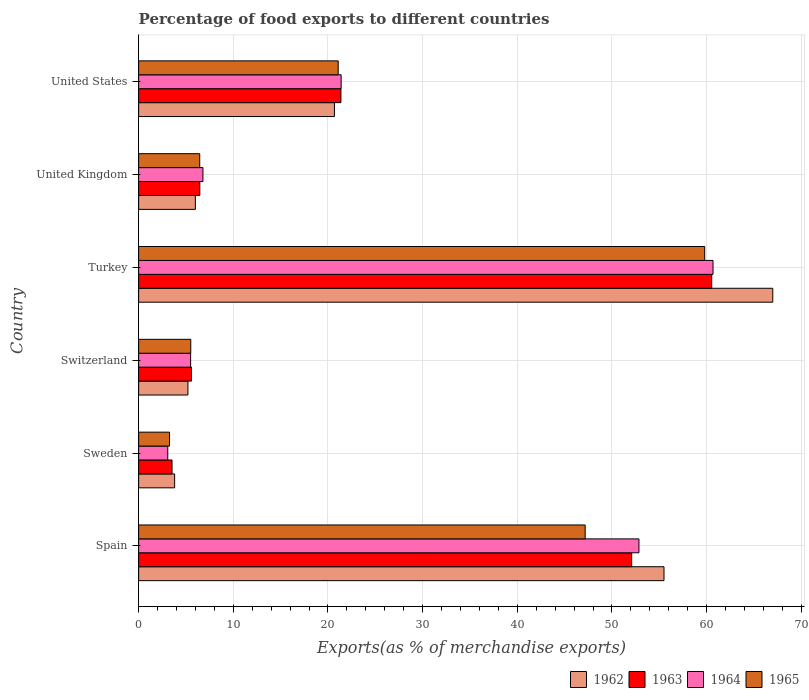How many different coloured bars are there?
Provide a short and direct response. 4. Are the number of bars on each tick of the Y-axis equal?
Provide a succinct answer. Yes. What is the label of the 4th group of bars from the top?
Offer a terse response. Switzerland. In how many cases, is the number of bars for a given country not equal to the number of legend labels?
Your response must be concise. 0. What is the percentage of exports to different countries in 1963 in Spain?
Provide a short and direct response. 52.09. Across all countries, what is the maximum percentage of exports to different countries in 1962?
Your answer should be very brief. 66.99. Across all countries, what is the minimum percentage of exports to different countries in 1965?
Your response must be concise. 3.27. What is the total percentage of exports to different countries in 1965 in the graph?
Ensure brevity in your answer.  143.28. What is the difference between the percentage of exports to different countries in 1965 in Sweden and that in Turkey?
Your answer should be very brief. -56.53. What is the difference between the percentage of exports to different countries in 1962 in Sweden and the percentage of exports to different countries in 1965 in United Kingdom?
Your answer should be very brief. -2.65. What is the average percentage of exports to different countries in 1963 per country?
Offer a terse response. 24.93. What is the difference between the percentage of exports to different countries in 1962 and percentage of exports to different countries in 1964 in Turkey?
Make the answer very short. 6.31. What is the ratio of the percentage of exports to different countries in 1962 in Switzerland to that in United States?
Your answer should be compact. 0.25. Is the difference between the percentage of exports to different countries in 1962 in Sweden and United Kingdom greater than the difference between the percentage of exports to different countries in 1964 in Sweden and United Kingdom?
Give a very brief answer. Yes. What is the difference between the highest and the second highest percentage of exports to different countries in 1963?
Ensure brevity in your answer.  8.46. What is the difference between the highest and the lowest percentage of exports to different countries in 1965?
Ensure brevity in your answer.  56.53. In how many countries, is the percentage of exports to different countries in 1962 greater than the average percentage of exports to different countries in 1962 taken over all countries?
Ensure brevity in your answer.  2. Is the sum of the percentage of exports to different countries in 1964 in Sweden and United Kingdom greater than the maximum percentage of exports to different countries in 1965 across all countries?
Provide a short and direct response. No. Is it the case that in every country, the sum of the percentage of exports to different countries in 1965 and percentage of exports to different countries in 1962 is greater than the sum of percentage of exports to different countries in 1964 and percentage of exports to different countries in 1963?
Provide a short and direct response. No. What does the 4th bar from the top in United Kingdom represents?
Give a very brief answer. 1962. Are all the bars in the graph horizontal?
Provide a short and direct response. Yes. What is the difference between two consecutive major ticks on the X-axis?
Give a very brief answer. 10. Does the graph contain grids?
Your answer should be very brief. Yes. Where does the legend appear in the graph?
Your answer should be very brief. Bottom right. What is the title of the graph?
Provide a succinct answer. Percentage of food exports to different countries. Does "1994" appear as one of the legend labels in the graph?
Ensure brevity in your answer.  No. What is the label or title of the X-axis?
Offer a very short reply. Exports(as % of merchandise exports). What is the Exports(as % of merchandise exports) of 1962 in Spain?
Your response must be concise. 55.5. What is the Exports(as % of merchandise exports) of 1963 in Spain?
Make the answer very short. 52.09. What is the Exports(as % of merchandise exports) of 1964 in Spain?
Ensure brevity in your answer.  52.85. What is the Exports(as % of merchandise exports) in 1965 in Spain?
Your answer should be compact. 47.17. What is the Exports(as % of merchandise exports) in 1962 in Sweden?
Your answer should be compact. 3.8. What is the Exports(as % of merchandise exports) of 1963 in Sweden?
Your response must be concise. 3.53. What is the Exports(as % of merchandise exports) in 1964 in Sweden?
Your answer should be compact. 3.08. What is the Exports(as % of merchandise exports) in 1965 in Sweden?
Provide a succinct answer. 3.27. What is the Exports(as % of merchandise exports) in 1962 in Switzerland?
Your answer should be very brief. 5.21. What is the Exports(as % of merchandise exports) in 1963 in Switzerland?
Offer a terse response. 5.59. What is the Exports(as % of merchandise exports) in 1964 in Switzerland?
Ensure brevity in your answer.  5.49. What is the Exports(as % of merchandise exports) of 1965 in Switzerland?
Give a very brief answer. 5.51. What is the Exports(as % of merchandise exports) of 1962 in Turkey?
Your response must be concise. 66.99. What is the Exports(as % of merchandise exports) of 1963 in Turkey?
Make the answer very short. 60.54. What is the Exports(as % of merchandise exports) in 1964 in Turkey?
Keep it short and to the point. 60.68. What is the Exports(as % of merchandise exports) of 1965 in Turkey?
Provide a succinct answer. 59.8. What is the Exports(as % of merchandise exports) in 1962 in United Kingdom?
Ensure brevity in your answer.  5.99. What is the Exports(as % of merchandise exports) in 1963 in United Kingdom?
Offer a very short reply. 6.47. What is the Exports(as % of merchandise exports) in 1964 in United Kingdom?
Keep it short and to the point. 6.79. What is the Exports(as % of merchandise exports) in 1965 in United Kingdom?
Keep it short and to the point. 6.45. What is the Exports(as % of merchandise exports) of 1962 in United States?
Your answer should be very brief. 20.68. What is the Exports(as % of merchandise exports) in 1963 in United States?
Offer a very short reply. 21.37. What is the Exports(as % of merchandise exports) of 1964 in United States?
Offer a very short reply. 21.39. What is the Exports(as % of merchandise exports) of 1965 in United States?
Your response must be concise. 21.08. Across all countries, what is the maximum Exports(as % of merchandise exports) of 1962?
Provide a succinct answer. 66.99. Across all countries, what is the maximum Exports(as % of merchandise exports) in 1963?
Provide a short and direct response. 60.54. Across all countries, what is the maximum Exports(as % of merchandise exports) in 1964?
Your response must be concise. 60.68. Across all countries, what is the maximum Exports(as % of merchandise exports) in 1965?
Your answer should be very brief. 59.8. Across all countries, what is the minimum Exports(as % of merchandise exports) of 1962?
Your response must be concise. 3.8. Across all countries, what is the minimum Exports(as % of merchandise exports) in 1963?
Your answer should be compact. 3.53. Across all countries, what is the minimum Exports(as % of merchandise exports) of 1964?
Offer a very short reply. 3.08. Across all countries, what is the minimum Exports(as % of merchandise exports) of 1965?
Ensure brevity in your answer.  3.27. What is the total Exports(as % of merchandise exports) in 1962 in the graph?
Keep it short and to the point. 158.19. What is the total Exports(as % of merchandise exports) in 1963 in the graph?
Offer a very short reply. 149.58. What is the total Exports(as % of merchandise exports) in 1964 in the graph?
Your response must be concise. 150.29. What is the total Exports(as % of merchandise exports) in 1965 in the graph?
Your answer should be compact. 143.28. What is the difference between the Exports(as % of merchandise exports) of 1962 in Spain and that in Sweden?
Ensure brevity in your answer.  51.7. What is the difference between the Exports(as % of merchandise exports) in 1963 in Spain and that in Sweden?
Provide a succinct answer. 48.56. What is the difference between the Exports(as % of merchandise exports) in 1964 in Spain and that in Sweden?
Keep it short and to the point. 49.77. What is the difference between the Exports(as % of merchandise exports) of 1965 in Spain and that in Sweden?
Provide a succinct answer. 43.9. What is the difference between the Exports(as % of merchandise exports) in 1962 in Spain and that in Switzerland?
Your answer should be compact. 50.29. What is the difference between the Exports(as % of merchandise exports) of 1963 in Spain and that in Switzerland?
Give a very brief answer. 46.5. What is the difference between the Exports(as % of merchandise exports) in 1964 in Spain and that in Switzerland?
Ensure brevity in your answer.  47.36. What is the difference between the Exports(as % of merchandise exports) of 1965 in Spain and that in Switzerland?
Offer a very short reply. 41.67. What is the difference between the Exports(as % of merchandise exports) of 1962 in Spain and that in Turkey?
Offer a terse response. -11.49. What is the difference between the Exports(as % of merchandise exports) in 1963 in Spain and that in Turkey?
Keep it short and to the point. -8.46. What is the difference between the Exports(as % of merchandise exports) of 1964 in Spain and that in Turkey?
Provide a short and direct response. -7.83. What is the difference between the Exports(as % of merchandise exports) of 1965 in Spain and that in Turkey?
Offer a terse response. -12.63. What is the difference between the Exports(as % of merchandise exports) of 1962 in Spain and that in United Kingdom?
Ensure brevity in your answer.  49.51. What is the difference between the Exports(as % of merchandise exports) of 1963 in Spain and that in United Kingdom?
Provide a succinct answer. 45.62. What is the difference between the Exports(as % of merchandise exports) in 1964 in Spain and that in United Kingdom?
Your answer should be compact. 46.06. What is the difference between the Exports(as % of merchandise exports) of 1965 in Spain and that in United Kingdom?
Make the answer very short. 40.72. What is the difference between the Exports(as % of merchandise exports) in 1962 in Spain and that in United States?
Offer a terse response. 34.82. What is the difference between the Exports(as % of merchandise exports) of 1963 in Spain and that in United States?
Offer a very short reply. 30.71. What is the difference between the Exports(as % of merchandise exports) of 1964 in Spain and that in United States?
Provide a short and direct response. 31.46. What is the difference between the Exports(as % of merchandise exports) of 1965 in Spain and that in United States?
Provide a succinct answer. 26.09. What is the difference between the Exports(as % of merchandise exports) in 1962 in Sweden and that in Switzerland?
Keep it short and to the point. -1.4. What is the difference between the Exports(as % of merchandise exports) of 1963 in Sweden and that in Switzerland?
Your response must be concise. -2.06. What is the difference between the Exports(as % of merchandise exports) in 1964 in Sweden and that in Switzerland?
Provide a succinct answer. -2.41. What is the difference between the Exports(as % of merchandise exports) of 1965 in Sweden and that in Switzerland?
Ensure brevity in your answer.  -2.24. What is the difference between the Exports(as % of merchandise exports) in 1962 in Sweden and that in Turkey?
Give a very brief answer. -63.19. What is the difference between the Exports(as % of merchandise exports) of 1963 in Sweden and that in Turkey?
Give a very brief answer. -57.01. What is the difference between the Exports(as % of merchandise exports) in 1964 in Sweden and that in Turkey?
Keep it short and to the point. -57.6. What is the difference between the Exports(as % of merchandise exports) in 1965 in Sweden and that in Turkey?
Provide a short and direct response. -56.53. What is the difference between the Exports(as % of merchandise exports) in 1962 in Sweden and that in United Kingdom?
Keep it short and to the point. -2.19. What is the difference between the Exports(as % of merchandise exports) in 1963 in Sweden and that in United Kingdom?
Ensure brevity in your answer.  -2.94. What is the difference between the Exports(as % of merchandise exports) of 1964 in Sweden and that in United Kingdom?
Your response must be concise. -3.71. What is the difference between the Exports(as % of merchandise exports) in 1965 in Sweden and that in United Kingdom?
Give a very brief answer. -3.19. What is the difference between the Exports(as % of merchandise exports) of 1962 in Sweden and that in United States?
Keep it short and to the point. -16.88. What is the difference between the Exports(as % of merchandise exports) of 1963 in Sweden and that in United States?
Your answer should be very brief. -17.84. What is the difference between the Exports(as % of merchandise exports) in 1964 in Sweden and that in United States?
Keep it short and to the point. -18.31. What is the difference between the Exports(as % of merchandise exports) of 1965 in Sweden and that in United States?
Your answer should be compact. -17.82. What is the difference between the Exports(as % of merchandise exports) in 1962 in Switzerland and that in Turkey?
Your answer should be very brief. -61.78. What is the difference between the Exports(as % of merchandise exports) in 1963 in Switzerland and that in Turkey?
Your answer should be compact. -54.96. What is the difference between the Exports(as % of merchandise exports) of 1964 in Switzerland and that in Turkey?
Give a very brief answer. -55.18. What is the difference between the Exports(as % of merchandise exports) of 1965 in Switzerland and that in Turkey?
Your answer should be compact. -54.29. What is the difference between the Exports(as % of merchandise exports) of 1962 in Switzerland and that in United Kingdom?
Make the answer very short. -0.78. What is the difference between the Exports(as % of merchandise exports) in 1963 in Switzerland and that in United Kingdom?
Make the answer very short. -0.88. What is the difference between the Exports(as % of merchandise exports) in 1964 in Switzerland and that in United Kingdom?
Your response must be concise. -1.3. What is the difference between the Exports(as % of merchandise exports) in 1965 in Switzerland and that in United Kingdom?
Offer a very short reply. -0.95. What is the difference between the Exports(as % of merchandise exports) of 1962 in Switzerland and that in United States?
Provide a short and direct response. -15.48. What is the difference between the Exports(as % of merchandise exports) of 1963 in Switzerland and that in United States?
Your answer should be very brief. -15.79. What is the difference between the Exports(as % of merchandise exports) in 1964 in Switzerland and that in United States?
Give a very brief answer. -15.9. What is the difference between the Exports(as % of merchandise exports) in 1965 in Switzerland and that in United States?
Make the answer very short. -15.58. What is the difference between the Exports(as % of merchandise exports) of 1962 in Turkey and that in United Kingdom?
Your response must be concise. 61. What is the difference between the Exports(as % of merchandise exports) in 1963 in Turkey and that in United Kingdom?
Offer a terse response. 54.08. What is the difference between the Exports(as % of merchandise exports) in 1964 in Turkey and that in United Kingdom?
Provide a short and direct response. 53.88. What is the difference between the Exports(as % of merchandise exports) in 1965 in Turkey and that in United Kingdom?
Offer a very short reply. 53.34. What is the difference between the Exports(as % of merchandise exports) of 1962 in Turkey and that in United States?
Offer a terse response. 46.31. What is the difference between the Exports(as % of merchandise exports) in 1963 in Turkey and that in United States?
Offer a very short reply. 39.17. What is the difference between the Exports(as % of merchandise exports) in 1964 in Turkey and that in United States?
Provide a short and direct response. 39.28. What is the difference between the Exports(as % of merchandise exports) of 1965 in Turkey and that in United States?
Your response must be concise. 38.72. What is the difference between the Exports(as % of merchandise exports) of 1962 in United Kingdom and that in United States?
Offer a very short reply. -14.69. What is the difference between the Exports(as % of merchandise exports) in 1963 in United Kingdom and that in United States?
Offer a terse response. -14.91. What is the difference between the Exports(as % of merchandise exports) in 1964 in United Kingdom and that in United States?
Offer a very short reply. -14.6. What is the difference between the Exports(as % of merchandise exports) of 1965 in United Kingdom and that in United States?
Provide a succinct answer. -14.63. What is the difference between the Exports(as % of merchandise exports) in 1962 in Spain and the Exports(as % of merchandise exports) in 1963 in Sweden?
Keep it short and to the point. 51.97. What is the difference between the Exports(as % of merchandise exports) of 1962 in Spain and the Exports(as % of merchandise exports) of 1964 in Sweden?
Your answer should be compact. 52.42. What is the difference between the Exports(as % of merchandise exports) of 1962 in Spain and the Exports(as % of merchandise exports) of 1965 in Sweden?
Provide a succinct answer. 52.23. What is the difference between the Exports(as % of merchandise exports) of 1963 in Spain and the Exports(as % of merchandise exports) of 1964 in Sweden?
Your response must be concise. 49.01. What is the difference between the Exports(as % of merchandise exports) in 1963 in Spain and the Exports(as % of merchandise exports) in 1965 in Sweden?
Keep it short and to the point. 48.82. What is the difference between the Exports(as % of merchandise exports) of 1964 in Spain and the Exports(as % of merchandise exports) of 1965 in Sweden?
Give a very brief answer. 49.58. What is the difference between the Exports(as % of merchandise exports) in 1962 in Spain and the Exports(as % of merchandise exports) in 1963 in Switzerland?
Give a very brief answer. 49.92. What is the difference between the Exports(as % of merchandise exports) in 1962 in Spain and the Exports(as % of merchandise exports) in 1964 in Switzerland?
Provide a succinct answer. 50.01. What is the difference between the Exports(as % of merchandise exports) of 1962 in Spain and the Exports(as % of merchandise exports) of 1965 in Switzerland?
Give a very brief answer. 49.99. What is the difference between the Exports(as % of merchandise exports) of 1963 in Spain and the Exports(as % of merchandise exports) of 1964 in Switzerland?
Provide a succinct answer. 46.59. What is the difference between the Exports(as % of merchandise exports) in 1963 in Spain and the Exports(as % of merchandise exports) in 1965 in Switzerland?
Keep it short and to the point. 46.58. What is the difference between the Exports(as % of merchandise exports) in 1964 in Spain and the Exports(as % of merchandise exports) in 1965 in Switzerland?
Keep it short and to the point. 47.35. What is the difference between the Exports(as % of merchandise exports) of 1962 in Spain and the Exports(as % of merchandise exports) of 1963 in Turkey?
Make the answer very short. -5.04. What is the difference between the Exports(as % of merchandise exports) in 1962 in Spain and the Exports(as % of merchandise exports) in 1964 in Turkey?
Offer a very short reply. -5.18. What is the difference between the Exports(as % of merchandise exports) in 1962 in Spain and the Exports(as % of merchandise exports) in 1965 in Turkey?
Offer a terse response. -4.3. What is the difference between the Exports(as % of merchandise exports) of 1963 in Spain and the Exports(as % of merchandise exports) of 1964 in Turkey?
Give a very brief answer. -8.59. What is the difference between the Exports(as % of merchandise exports) of 1963 in Spain and the Exports(as % of merchandise exports) of 1965 in Turkey?
Your answer should be very brief. -7.71. What is the difference between the Exports(as % of merchandise exports) of 1964 in Spain and the Exports(as % of merchandise exports) of 1965 in Turkey?
Provide a succinct answer. -6.95. What is the difference between the Exports(as % of merchandise exports) of 1962 in Spain and the Exports(as % of merchandise exports) of 1963 in United Kingdom?
Give a very brief answer. 49.04. What is the difference between the Exports(as % of merchandise exports) in 1962 in Spain and the Exports(as % of merchandise exports) in 1964 in United Kingdom?
Provide a succinct answer. 48.71. What is the difference between the Exports(as % of merchandise exports) of 1962 in Spain and the Exports(as % of merchandise exports) of 1965 in United Kingdom?
Offer a very short reply. 49.05. What is the difference between the Exports(as % of merchandise exports) in 1963 in Spain and the Exports(as % of merchandise exports) in 1964 in United Kingdom?
Provide a short and direct response. 45.29. What is the difference between the Exports(as % of merchandise exports) of 1963 in Spain and the Exports(as % of merchandise exports) of 1965 in United Kingdom?
Your answer should be compact. 45.63. What is the difference between the Exports(as % of merchandise exports) in 1964 in Spain and the Exports(as % of merchandise exports) in 1965 in United Kingdom?
Make the answer very short. 46.4. What is the difference between the Exports(as % of merchandise exports) of 1962 in Spain and the Exports(as % of merchandise exports) of 1963 in United States?
Offer a terse response. 34.13. What is the difference between the Exports(as % of merchandise exports) in 1962 in Spain and the Exports(as % of merchandise exports) in 1964 in United States?
Provide a succinct answer. 34.11. What is the difference between the Exports(as % of merchandise exports) of 1962 in Spain and the Exports(as % of merchandise exports) of 1965 in United States?
Offer a terse response. 34.42. What is the difference between the Exports(as % of merchandise exports) in 1963 in Spain and the Exports(as % of merchandise exports) in 1964 in United States?
Offer a very short reply. 30.69. What is the difference between the Exports(as % of merchandise exports) of 1963 in Spain and the Exports(as % of merchandise exports) of 1965 in United States?
Offer a very short reply. 31. What is the difference between the Exports(as % of merchandise exports) of 1964 in Spain and the Exports(as % of merchandise exports) of 1965 in United States?
Provide a short and direct response. 31.77. What is the difference between the Exports(as % of merchandise exports) of 1962 in Sweden and the Exports(as % of merchandise exports) of 1963 in Switzerland?
Your answer should be compact. -1.78. What is the difference between the Exports(as % of merchandise exports) of 1962 in Sweden and the Exports(as % of merchandise exports) of 1964 in Switzerland?
Offer a terse response. -1.69. What is the difference between the Exports(as % of merchandise exports) of 1962 in Sweden and the Exports(as % of merchandise exports) of 1965 in Switzerland?
Provide a succinct answer. -1.7. What is the difference between the Exports(as % of merchandise exports) in 1963 in Sweden and the Exports(as % of merchandise exports) in 1964 in Switzerland?
Your response must be concise. -1.96. What is the difference between the Exports(as % of merchandise exports) of 1963 in Sweden and the Exports(as % of merchandise exports) of 1965 in Switzerland?
Provide a short and direct response. -1.98. What is the difference between the Exports(as % of merchandise exports) in 1964 in Sweden and the Exports(as % of merchandise exports) in 1965 in Switzerland?
Provide a short and direct response. -2.43. What is the difference between the Exports(as % of merchandise exports) in 1962 in Sweden and the Exports(as % of merchandise exports) in 1963 in Turkey?
Your response must be concise. -56.74. What is the difference between the Exports(as % of merchandise exports) in 1962 in Sweden and the Exports(as % of merchandise exports) in 1964 in Turkey?
Offer a very short reply. -56.87. What is the difference between the Exports(as % of merchandise exports) in 1962 in Sweden and the Exports(as % of merchandise exports) in 1965 in Turkey?
Your answer should be very brief. -55.99. What is the difference between the Exports(as % of merchandise exports) of 1963 in Sweden and the Exports(as % of merchandise exports) of 1964 in Turkey?
Provide a short and direct response. -57.15. What is the difference between the Exports(as % of merchandise exports) in 1963 in Sweden and the Exports(as % of merchandise exports) in 1965 in Turkey?
Ensure brevity in your answer.  -56.27. What is the difference between the Exports(as % of merchandise exports) in 1964 in Sweden and the Exports(as % of merchandise exports) in 1965 in Turkey?
Offer a very short reply. -56.72. What is the difference between the Exports(as % of merchandise exports) in 1962 in Sweden and the Exports(as % of merchandise exports) in 1963 in United Kingdom?
Your answer should be very brief. -2.66. What is the difference between the Exports(as % of merchandise exports) in 1962 in Sweden and the Exports(as % of merchandise exports) in 1964 in United Kingdom?
Give a very brief answer. -2.99. What is the difference between the Exports(as % of merchandise exports) of 1962 in Sweden and the Exports(as % of merchandise exports) of 1965 in United Kingdom?
Offer a very short reply. -2.65. What is the difference between the Exports(as % of merchandise exports) of 1963 in Sweden and the Exports(as % of merchandise exports) of 1964 in United Kingdom?
Ensure brevity in your answer.  -3.26. What is the difference between the Exports(as % of merchandise exports) in 1963 in Sweden and the Exports(as % of merchandise exports) in 1965 in United Kingdom?
Your answer should be very brief. -2.93. What is the difference between the Exports(as % of merchandise exports) in 1964 in Sweden and the Exports(as % of merchandise exports) in 1965 in United Kingdom?
Ensure brevity in your answer.  -3.38. What is the difference between the Exports(as % of merchandise exports) in 1962 in Sweden and the Exports(as % of merchandise exports) in 1963 in United States?
Offer a terse response. -17.57. What is the difference between the Exports(as % of merchandise exports) in 1962 in Sweden and the Exports(as % of merchandise exports) in 1964 in United States?
Your response must be concise. -17.59. What is the difference between the Exports(as % of merchandise exports) of 1962 in Sweden and the Exports(as % of merchandise exports) of 1965 in United States?
Keep it short and to the point. -17.28. What is the difference between the Exports(as % of merchandise exports) of 1963 in Sweden and the Exports(as % of merchandise exports) of 1964 in United States?
Provide a succinct answer. -17.86. What is the difference between the Exports(as % of merchandise exports) in 1963 in Sweden and the Exports(as % of merchandise exports) in 1965 in United States?
Your answer should be compact. -17.55. What is the difference between the Exports(as % of merchandise exports) in 1964 in Sweden and the Exports(as % of merchandise exports) in 1965 in United States?
Provide a short and direct response. -18. What is the difference between the Exports(as % of merchandise exports) of 1962 in Switzerland and the Exports(as % of merchandise exports) of 1963 in Turkey?
Your response must be concise. -55.33. What is the difference between the Exports(as % of merchandise exports) in 1962 in Switzerland and the Exports(as % of merchandise exports) in 1964 in Turkey?
Provide a short and direct response. -55.47. What is the difference between the Exports(as % of merchandise exports) of 1962 in Switzerland and the Exports(as % of merchandise exports) of 1965 in Turkey?
Your answer should be very brief. -54.59. What is the difference between the Exports(as % of merchandise exports) in 1963 in Switzerland and the Exports(as % of merchandise exports) in 1964 in Turkey?
Offer a very short reply. -55.09. What is the difference between the Exports(as % of merchandise exports) in 1963 in Switzerland and the Exports(as % of merchandise exports) in 1965 in Turkey?
Make the answer very short. -54.21. What is the difference between the Exports(as % of merchandise exports) in 1964 in Switzerland and the Exports(as % of merchandise exports) in 1965 in Turkey?
Your answer should be very brief. -54.31. What is the difference between the Exports(as % of merchandise exports) of 1962 in Switzerland and the Exports(as % of merchandise exports) of 1963 in United Kingdom?
Offer a terse response. -1.26. What is the difference between the Exports(as % of merchandise exports) of 1962 in Switzerland and the Exports(as % of merchandise exports) of 1964 in United Kingdom?
Provide a succinct answer. -1.58. What is the difference between the Exports(as % of merchandise exports) in 1962 in Switzerland and the Exports(as % of merchandise exports) in 1965 in United Kingdom?
Your answer should be compact. -1.25. What is the difference between the Exports(as % of merchandise exports) of 1963 in Switzerland and the Exports(as % of merchandise exports) of 1964 in United Kingdom?
Your answer should be compact. -1.21. What is the difference between the Exports(as % of merchandise exports) of 1963 in Switzerland and the Exports(as % of merchandise exports) of 1965 in United Kingdom?
Provide a succinct answer. -0.87. What is the difference between the Exports(as % of merchandise exports) of 1964 in Switzerland and the Exports(as % of merchandise exports) of 1965 in United Kingdom?
Ensure brevity in your answer.  -0.96. What is the difference between the Exports(as % of merchandise exports) in 1962 in Switzerland and the Exports(as % of merchandise exports) in 1963 in United States?
Provide a short and direct response. -16.16. What is the difference between the Exports(as % of merchandise exports) of 1962 in Switzerland and the Exports(as % of merchandise exports) of 1964 in United States?
Give a very brief answer. -16.18. What is the difference between the Exports(as % of merchandise exports) in 1962 in Switzerland and the Exports(as % of merchandise exports) in 1965 in United States?
Make the answer very short. -15.87. What is the difference between the Exports(as % of merchandise exports) in 1963 in Switzerland and the Exports(as % of merchandise exports) in 1964 in United States?
Your answer should be very brief. -15.81. What is the difference between the Exports(as % of merchandise exports) in 1963 in Switzerland and the Exports(as % of merchandise exports) in 1965 in United States?
Your answer should be very brief. -15.5. What is the difference between the Exports(as % of merchandise exports) in 1964 in Switzerland and the Exports(as % of merchandise exports) in 1965 in United States?
Ensure brevity in your answer.  -15.59. What is the difference between the Exports(as % of merchandise exports) in 1962 in Turkey and the Exports(as % of merchandise exports) in 1963 in United Kingdom?
Your response must be concise. 60.53. What is the difference between the Exports(as % of merchandise exports) in 1962 in Turkey and the Exports(as % of merchandise exports) in 1964 in United Kingdom?
Your answer should be compact. 60.2. What is the difference between the Exports(as % of merchandise exports) in 1962 in Turkey and the Exports(as % of merchandise exports) in 1965 in United Kingdom?
Make the answer very short. 60.54. What is the difference between the Exports(as % of merchandise exports) in 1963 in Turkey and the Exports(as % of merchandise exports) in 1964 in United Kingdom?
Ensure brevity in your answer.  53.75. What is the difference between the Exports(as % of merchandise exports) of 1963 in Turkey and the Exports(as % of merchandise exports) of 1965 in United Kingdom?
Make the answer very short. 54.09. What is the difference between the Exports(as % of merchandise exports) in 1964 in Turkey and the Exports(as % of merchandise exports) in 1965 in United Kingdom?
Provide a short and direct response. 54.22. What is the difference between the Exports(as % of merchandise exports) of 1962 in Turkey and the Exports(as % of merchandise exports) of 1963 in United States?
Make the answer very short. 45.62. What is the difference between the Exports(as % of merchandise exports) in 1962 in Turkey and the Exports(as % of merchandise exports) in 1964 in United States?
Give a very brief answer. 45.6. What is the difference between the Exports(as % of merchandise exports) in 1962 in Turkey and the Exports(as % of merchandise exports) in 1965 in United States?
Give a very brief answer. 45.91. What is the difference between the Exports(as % of merchandise exports) of 1963 in Turkey and the Exports(as % of merchandise exports) of 1964 in United States?
Offer a very short reply. 39.15. What is the difference between the Exports(as % of merchandise exports) in 1963 in Turkey and the Exports(as % of merchandise exports) in 1965 in United States?
Offer a terse response. 39.46. What is the difference between the Exports(as % of merchandise exports) in 1964 in Turkey and the Exports(as % of merchandise exports) in 1965 in United States?
Your answer should be very brief. 39.59. What is the difference between the Exports(as % of merchandise exports) in 1962 in United Kingdom and the Exports(as % of merchandise exports) in 1963 in United States?
Keep it short and to the point. -15.38. What is the difference between the Exports(as % of merchandise exports) in 1962 in United Kingdom and the Exports(as % of merchandise exports) in 1964 in United States?
Your response must be concise. -15.4. What is the difference between the Exports(as % of merchandise exports) in 1962 in United Kingdom and the Exports(as % of merchandise exports) in 1965 in United States?
Your answer should be compact. -15.09. What is the difference between the Exports(as % of merchandise exports) in 1963 in United Kingdom and the Exports(as % of merchandise exports) in 1964 in United States?
Keep it short and to the point. -14.93. What is the difference between the Exports(as % of merchandise exports) of 1963 in United Kingdom and the Exports(as % of merchandise exports) of 1965 in United States?
Make the answer very short. -14.62. What is the difference between the Exports(as % of merchandise exports) in 1964 in United Kingdom and the Exports(as % of merchandise exports) in 1965 in United States?
Keep it short and to the point. -14.29. What is the average Exports(as % of merchandise exports) of 1962 per country?
Make the answer very short. 26.36. What is the average Exports(as % of merchandise exports) in 1963 per country?
Offer a very short reply. 24.93. What is the average Exports(as % of merchandise exports) in 1964 per country?
Your response must be concise. 25.05. What is the average Exports(as % of merchandise exports) of 1965 per country?
Your response must be concise. 23.88. What is the difference between the Exports(as % of merchandise exports) of 1962 and Exports(as % of merchandise exports) of 1963 in Spain?
Make the answer very short. 3.42. What is the difference between the Exports(as % of merchandise exports) in 1962 and Exports(as % of merchandise exports) in 1964 in Spain?
Your answer should be very brief. 2.65. What is the difference between the Exports(as % of merchandise exports) of 1962 and Exports(as % of merchandise exports) of 1965 in Spain?
Your answer should be compact. 8.33. What is the difference between the Exports(as % of merchandise exports) of 1963 and Exports(as % of merchandise exports) of 1964 in Spain?
Offer a terse response. -0.77. What is the difference between the Exports(as % of merchandise exports) in 1963 and Exports(as % of merchandise exports) in 1965 in Spain?
Give a very brief answer. 4.91. What is the difference between the Exports(as % of merchandise exports) of 1964 and Exports(as % of merchandise exports) of 1965 in Spain?
Provide a succinct answer. 5.68. What is the difference between the Exports(as % of merchandise exports) in 1962 and Exports(as % of merchandise exports) in 1963 in Sweden?
Your answer should be compact. 0.28. What is the difference between the Exports(as % of merchandise exports) in 1962 and Exports(as % of merchandise exports) in 1964 in Sweden?
Offer a very short reply. 0.73. What is the difference between the Exports(as % of merchandise exports) of 1962 and Exports(as % of merchandise exports) of 1965 in Sweden?
Give a very brief answer. 0.54. What is the difference between the Exports(as % of merchandise exports) of 1963 and Exports(as % of merchandise exports) of 1964 in Sweden?
Offer a very short reply. 0.45. What is the difference between the Exports(as % of merchandise exports) of 1963 and Exports(as % of merchandise exports) of 1965 in Sweden?
Offer a very short reply. 0.26. What is the difference between the Exports(as % of merchandise exports) in 1964 and Exports(as % of merchandise exports) in 1965 in Sweden?
Provide a succinct answer. -0.19. What is the difference between the Exports(as % of merchandise exports) in 1962 and Exports(as % of merchandise exports) in 1963 in Switzerland?
Keep it short and to the point. -0.38. What is the difference between the Exports(as % of merchandise exports) of 1962 and Exports(as % of merchandise exports) of 1964 in Switzerland?
Keep it short and to the point. -0.28. What is the difference between the Exports(as % of merchandise exports) of 1962 and Exports(as % of merchandise exports) of 1965 in Switzerland?
Give a very brief answer. -0.3. What is the difference between the Exports(as % of merchandise exports) of 1963 and Exports(as % of merchandise exports) of 1964 in Switzerland?
Keep it short and to the point. 0.09. What is the difference between the Exports(as % of merchandise exports) of 1963 and Exports(as % of merchandise exports) of 1965 in Switzerland?
Provide a short and direct response. 0.08. What is the difference between the Exports(as % of merchandise exports) in 1964 and Exports(as % of merchandise exports) in 1965 in Switzerland?
Your answer should be very brief. -0.01. What is the difference between the Exports(as % of merchandise exports) in 1962 and Exports(as % of merchandise exports) in 1963 in Turkey?
Offer a terse response. 6.45. What is the difference between the Exports(as % of merchandise exports) in 1962 and Exports(as % of merchandise exports) in 1964 in Turkey?
Give a very brief answer. 6.31. What is the difference between the Exports(as % of merchandise exports) of 1962 and Exports(as % of merchandise exports) of 1965 in Turkey?
Give a very brief answer. 7.19. What is the difference between the Exports(as % of merchandise exports) in 1963 and Exports(as % of merchandise exports) in 1964 in Turkey?
Provide a short and direct response. -0.14. What is the difference between the Exports(as % of merchandise exports) in 1963 and Exports(as % of merchandise exports) in 1965 in Turkey?
Offer a terse response. 0.74. What is the difference between the Exports(as % of merchandise exports) of 1964 and Exports(as % of merchandise exports) of 1965 in Turkey?
Provide a succinct answer. 0.88. What is the difference between the Exports(as % of merchandise exports) of 1962 and Exports(as % of merchandise exports) of 1963 in United Kingdom?
Provide a succinct answer. -0.47. What is the difference between the Exports(as % of merchandise exports) of 1962 and Exports(as % of merchandise exports) of 1964 in United Kingdom?
Your answer should be very brief. -0.8. What is the difference between the Exports(as % of merchandise exports) of 1962 and Exports(as % of merchandise exports) of 1965 in United Kingdom?
Offer a terse response. -0.46. What is the difference between the Exports(as % of merchandise exports) in 1963 and Exports(as % of merchandise exports) in 1964 in United Kingdom?
Keep it short and to the point. -0.33. What is the difference between the Exports(as % of merchandise exports) of 1963 and Exports(as % of merchandise exports) of 1965 in United Kingdom?
Offer a very short reply. 0.01. What is the difference between the Exports(as % of merchandise exports) in 1964 and Exports(as % of merchandise exports) in 1965 in United Kingdom?
Your response must be concise. 0.34. What is the difference between the Exports(as % of merchandise exports) of 1962 and Exports(as % of merchandise exports) of 1963 in United States?
Your answer should be very brief. -0.69. What is the difference between the Exports(as % of merchandise exports) in 1962 and Exports(as % of merchandise exports) in 1964 in United States?
Provide a succinct answer. -0.71. What is the difference between the Exports(as % of merchandise exports) in 1962 and Exports(as % of merchandise exports) in 1965 in United States?
Ensure brevity in your answer.  -0.4. What is the difference between the Exports(as % of merchandise exports) in 1963 and Exports(as % of merchandise exports) in 1964 in United States?
Keep it short and to the point. -0.02. What is the difference between the Exports(as % of merchandise exports) in 1963 and Exports(as % of merchandise exports) in 1965 in United States?
Make the answer very short. 0.29. What is the difference between the Exports(as % of merchandise exports) of 1964 and Exports(as % of merchandise exports) of 1965 in United States?
Provide a short and direct response. 0.31. What is the ratio of the Exports(as % of merchandise exports) in 1962 in Spain to that in Sweden?
Your answer should be very brief. 14.59. What is the ratio of the Exports(as % of merchandise exports) of 1963 in Spain to that in Sweden?
Your answer should be compact. 14.76. What is the ratio of the Exports(as % of merchandise exports) of 1964 in Spain to that in Sweden?
Keep it short and to the point. 17.17. What is the ratio of the Exports(as % of merchandise exports) in 1965 in Spain to that in Sweden?
Provide a short and direct response. 14.44. What is the ratio of the Exports(as % of merchandise exports) in 1962 in Spain to that in Switzerland?
Keep it short and to the point. 10.65. What is the ratio of the Exports(as % of merchandise exports) in 1963 in Spain to that in Switzerland?
Keep it short and to the point. 9.33. What is the ratio of the Exports(as % of merchandise exports) of 1964 in Spain to that in Switzerland?
Provide a succinct answer. 9.62. What is the ratio of the Exports(as % of merchandise exports) of 1965 in Spain to that in Switzerland?
Provide a short and direct response. 8.57. What is the ratio of the Exports(as % of merchandise exports) in 1962 in Spain to that in Turkey?
Make the answer very short. 0.83. What is the ratio of the Exports(as % of merchandise exports) of 1963 in Spain to that in Turkey?
Give a very brief answer. 0.86. What is the ratio of the Exports(as % of merchandise exports) of 1964 in Spain to that in Turkey?
Your answer should be very brief. 0.87. What is the ratio of the Exports(as % of merchandise exports) of 1965 in Spain to that in Turkey?
Your answer should be very brief. 0.79. What is the ratio of the Exports(as % of merchandise exports) in 1962 in Spain to that in United Kingdom?
Give a very brief answer. 9.26. What is the ratio of the Exports(as % of merchandise exports) of 1963 in Spain to that in United Kingdom?
Ensure brevity in your answer.  8.06. What is the ratio of the Exports(as % of merchandise exports) of 1964 in Spain to that in United Kingdom?
Your answer should be compact. 7.78. What is the ratio of the Exports(as % of merchandise exports) of 1965 in Spain to that in United Kingdom?
Give a very brief answer. 7.31. What is the ratio of the Exports(as % of merchandise exports) in 1962 in Spain to that in United States?
Offer a very short reply. 2.68. What is the ratio of the Exports(as % of merchandise exports) in 1963 in Spain to that in United States?
Your answer should be compact. 2.44. What is the ratio of the Exports(as % of merchandise exports) of 1964 in Spain to that in United States?
Offer a terse response. 2.47. What is the ratio of the Exports(as % of merchandise exports) in 1965 in Spain to that in United States?
Offer a very short reply. 2.24. What is the ratio of the Exports(as % of merchandise exports) of 1962 in Sweden to that in Switzerland?
Provide a succinct answer. 0.73. What is the ratio of the Exports(as % of merchandise exports) of 1963 in Sweden to that in Switzerland?
Provide a succinct answer. 0.63. What is the ratio of the Exports(as % of merchandise exports) of 1964 in Sweden to that in Switzerland?
Provide a short and direct response. 0.56. What is the ratio of the Exports(as % of merchandise exports) in 1965 in Sweden to that in Switzerland?
Give a very brief answer. 0.59. What is the ratio of the Exports(as % of merchandise exports) of 1962 in Sweden to that in Turkey?
Your answer should be very brief. 0.06. What is the ratio of the Exports(as % of merchandise exports) of 1963 in Sweden to that in Turkey?
Your answer should be very brief. 0.06. What is the ratio of the Exports(as % of merchandise exports) in 1964 in Sweden to that in Turkey?
Keep it short and to the point. 0.05. What is the ratio of the Exports(as % of merchandise exports) in 1965 in Sweden to that in Turkey?
Offer a terse response. 0.05. What is the ratio of the Exports(as % of merchandise exports) in 1962 in Sweden to that in United Kingdom?
Provide a short and direct response. 0.63. What is the ratio of the Exports(as % of merchandise exports) of 1963 in Sweden to that in United Kingdom?
Offer a very short reply. 0.55. What is the ratio of the Exports(as % of merchandise exports) in 1964 in Sweden to that in United Kingdom?
Your answer should be compact. 0.45. What is the ratio of the Exports(as % of merchandise exports) in 1965 in Sweden to that in United Kingdom?
Ensure brevity in your answer.  0.51. What is the ratio of the Exports(as % of merchandise exports) in 1962 in Sweden to that in United States?
Offer a terse response. 0.18. What is the ratio of the Exports(as % of merchandise exports) in 1963 in Sweden to that in United States?
Your answer should be very brief. 0.17. What is the ratio of the Exports(as % of merchandise exports) in 1964 in Sweden to that in United States?
Offer a very short reply. 0.14. What is the ratio of the Exports(as % of merchandise exports) in 1965 in Sweden to that in United States?
Your answer should be compact. 0.15. What is the ratio of the Exports(as % of merchandise exports) in 1962 in Switzerland to that in Turkey?
Provide a short and direct response. 0.08. What is the ratio of the Exports(as % of merchandise exports) of 1963 in Switzerland to that in Turkey?
Keep it short and to the point. 0.09. What is the ratio of the Exports(as % of merchandise exports) of 1964 in Switzerland to that in Turkey?
Offer a very short reply. 0.09. What is the ratio of the Exports(as % of merchandise exports) in 1965 in Switzerland to that in Turkey?
Give a very brief answer. 0.09. What is the ratio of the Exports(as % of merchandise exports) in 1962 in Switzerland to that in United Kingdom?
Provide a short and direct response. 0.87. What is the ratio of the Exports(as % of merchandise exports) of 1963 in Switzerland to that in United Kingdom?
Ensure brevity in your answer.  0.86. What is the ratio of the Exports(as % of merchandise exports) in 1964 in Switzerland to that in United Kingdom?
Offer a terse response. 0.81. What is the ratio of the Exports(as % of merchandise exports) of 1965 in Switzerland to that in United Kingdom?
Offer a very short reply. 0.85. What is the ratio of the Exports(as % of merchandise exports) of 1962 in Switzerland to that in United States?
Your response must be concise. 0.25. What is the ratio of the Exports(as % of merchandise exports) of 1963 in Switzerland to that in United States?
Ensure brevity in your answer.  0.26. What is the ratio of the Exports(as % of merchandise exports) in 1964 in Switzerland to that in United States?
Provide a short and direct response. 0.26. What is the ratio of the Exports(as % of merchandise exports) in 1965 in Switzerland to that in United States?
Provide a succinct answer. 0.26. What is the ratio of the Exports(as % of merchandise exports) of 1962 in Turkey to that in United Kingdom?
Give a very brief answer. 11.18. What is the ratio of the Exports(as % of merchandise exports) of 1963 in Turkey to that in United Kingdom?
Provide a short and direct response. 9.36. What is the ratio of the Exports(as % of merchandise exports) in 1964 in Turkey to that in United Kingdom?
Keep it short and to the point. 8.93. What is the ratio of the Exports(as % of merchandise exports) of 1965 in Turkey to that in United Kingdom?
Your answer should be very brief. 9.26. What is the ratio of the Exports(as % of merchandise exports) of 1962 in Turkey to that in United States?
Your answer should be very brief. 3.24. What is the ratio of the Exports(as % of merchandise exports) in 1963 in Turkey to that in United States?
Make the answer very short. 2.83. What is the ratio of the Exports(as % of merchandise exports) of 1964 in Turkey to that in United States?
Give a very brief answer. 2.84. What is the ratio of the Exports(as % of merchandise exports) of 1965 in Turkey to that in United States?
Ensure brevity in your answer.  2.84. What is the ratio of the Exports(as % of merchandise exports) in 1962 in United Kingdom to that in United States?
Provide a succinct answer. 0.29. What is the ratio of the Exports(as % of merchandise exports) in 1963 in United Kingdom to that in United States?
Keep it short and to the point. 0.3. What is the ratio of the Exports(as % of merchandise exports) in 1964 in United Kingdom to that in United States?
Your answer should be very brief. 0.32. What is the ratio of the Exports(as % of merchandise exports) of 1965 in United Kingdom to that in United States?
Keep it short and to the point. 0.31. What is the difference between the highest and the second highest Exports(as % of merchandise exports) of 1962?
Offer a very short reply. 11.49. What is the difference between the highest and the second highest Exports(as % of merchandise exports) of 1963?
Offer a terse response. 8.46. What is the difference between the highest and the second highest Exports(as % of merchandise exports) in 1964?
Give a very brief answer. 7.83. What is the difference between the highest and the second highest Exports(as % of merchandise exports) in 1965?
Give a very brief answer. 12.63. What is the difference between the highest and the lowest Exports(as % of merchandise exports) of 1962?
Your response must be concise. 63.19. What is the difference between the highest and the lowest Exports(as % of merchandise exports) of 1963?
Make the answer very short. 57.01. What is the difference between the highest and the lowest Exports(as % of merchandise exports) of 1964?
Offer a very short reply. 57.6. What is the difference between the highest and the lowest Exports(as % of merchandise exports) in 1965?
Provide a succinct answer. 56.53. 